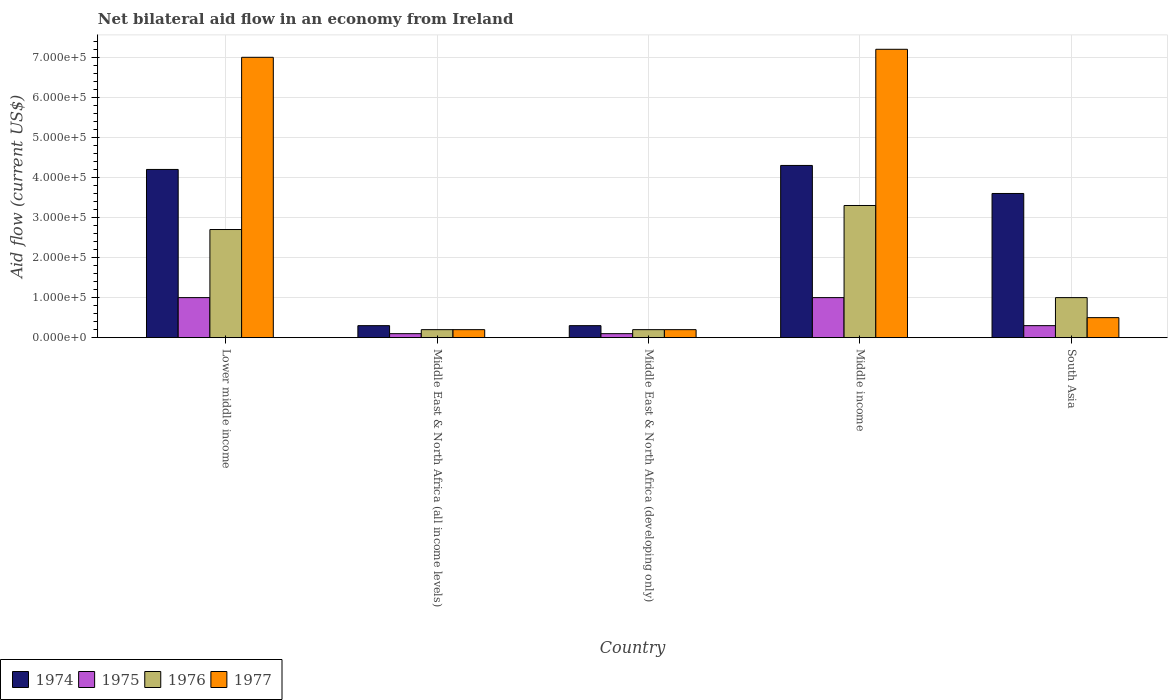How many groups of bars are there?
Your response must be concise. 5. Are the number of bars per tick equal to the number of legend labels?
Give a very brief answer. Yes. How many bars are there on the 5th tick from the right?
Provide a short and direct response. 4. What is the label of the 5th group of bars from the left?
Your answer should be compact. South Asia. In how many cases, is the number of bars for a given country not equal to the number of legend labels?
Keep it short and to the point. 0. Across all countries, what is the maximum net bilateral aid flow in 1977?
Give a very brief answer. 7.20e+05. In which country was the net bilateral aid flow in 1976 maximum?
Provide a short and direct response. Middle income. In which country was the net bilateral aid flow in 1977 minimum?
Your answer should be compact. Middle East & North Africa (all income levels). What is the total net bilateral aid flow in 1977 in the graph?
Your answer should be compact. 1.51e+06. What is the difference between the net bilateral aid flow in 1977 in Middle East & North Africa (all income levels) and that in Middle income?
Offer a terse response. -7.00e+05. What is the difference between the net bilateral aid flow in 1977 in Middle income and the net bilateral aid flow in 1975 in Middle East & North Africa (developing only)?
Make the answer very short. 7.10e+05. What is the average net bilateral aid flow in 1974 per country?
Provide a succinct answer. 2.54e+05. What is the ratio of the net bilateral aid flow in 1975 in Middle East & North Africa (developing only) to that in Middle income?
Provide a short and direct response. 0.1. Is the difference between the net bilateral aid flow in 1975 in Middle income and South Asia greater than the difference between the net bilateral aid flow in 1976 in Middle income and South Asia?
Provide a succinct answer. No. Is it the case that in every country, the sum of the net bilateral aid flow in 1974 and net bilateral aid flow in 1975 is greater than the sum of net bilateral aid flow in 1977 and net bilateral aid flow in 1976?
Offer a very short reply. No. What does the 2nd bar from the left in Middle East & North Africa (all income levels) represents?
Ensure brevity in your answer.  1975. Is it the case that in every country, the sum of the net bilateral aid flow in 1977 and net bilateral aid flow in 1976 is greater than the net bilateral aid flow in 1975?
Make the answer very short. Yes. How many countries are there in the graph?
Offer a very short reply. 5. Does the graph contain grids?
Provide a succinct answer. Yes. Where does the legend appear in the graph?
Ensure brevity in your answer.  Bottom left. How are the legend labels stacked?
Ensure brevity in your answer.  Horizontal. What is the title of the graph?
Your answer should be very brief. Net bilateral aid flow in an economy from Ireland. What is the label or title of the X-axis?
Your response must be concise. Country. What is the label or title of the Y-axis?
Keep it short and to the point. Aid flow (current US$). What is the Aid flow (current US$) of 1974 in Middle East & North Africa (all income levels)?
Your answer should be very brief. 3.00e+04. What is the Aid flow (current US$) of 1976 in Middle East & North Africa (all income levels)?
Offer a very short reply. 2.00e+04. What is the Aid flow (current US$) of 1977 in Middle East & North Africa (all income levels)?
Your answer should be compact. 2.00e+04. What is the Aid flow (current US$) of 1975 in Middle East & North Africa (developing only)?
Ensure brevity in your answer.  10000. What is the Aid flow (current US$) of 1974 in Middle income?
Your answer should be compact. 4.30e+05. What is the Aid flow (current US$) of 1975 in Middle income?
Your answer should be compact. 1.00e+05. What is the Aid flow (current US$) of 1976 in Middle income?
Your answer should be compact. 3.30e+05. What is the Aid flow (current US$) of 1977 in Middle income?
Make the answer very short. 7.20e+05. What is the Aid flow (current US$) in 1974 in South Asia?
Your answer should be very brief. 3.60e+05. What is the Aid flow (current US$) of 1975 in South Asia?
Keep it short and to the point. 3.00e+04. What is the Aid flow (current US$) of 1977 in South Asia?
Give a very brief answer. 5.00e+04. Across all countries, what is the maximum Aid flow (current US$) in 1977?
Offer a terse response. 7.20e+05. Across all countries, what is the minimum Aid flow (current US$) in 1976?
Ensure brevity in your answer.  2.00e+04. Across all countries, what is the minimum Aid flow (current US$) in 1977?
Make the answer very short. 2.00e+04. What is the total Aid flow (current US$) in 1974 in the graph?
Offer a terse response. 1.27e+06. What is the total Aid flow (current US$) in 1976 in the graph?
Give a very brief answer. 7.40e+05. What is the total Aid flow (current US$) in 1977 in the graph?
Provide a short and direct response. 1.51e+06. What is the difference between the Aid flow (current US$) in 1974 in Lower middle income and that in Middle East & North Africa (all income levels)?
Provide a succinct answer. 3.90e+05. What is the difference between the Aid flow (current US$) of 1975 in Lower middle income and that in Middle East & North Africa (all income levels)?
Your answer should be very brief. 9.00e+04. What is the difference between the Aid flow (current US$) of 1976 in Lower middle income and that in Middle East & North Africa (all income levels)?
Offer a terse response. 2.50e+05. What is the difference between the Aid flow (current US$) in 1977 in Lower middle income and that in Middle East & North Africa (all income levels)?
Provide a short and direct response. 6.80e+05. What is the difference between the Aid flow (current US$) of 1975 in Lower middle income and that in Middle East & North Africa (developing only)?
Your answer should be very brief. 9.00e+04. What is the difference between the Aid flow (current US$) in 1977 in Lower middle income and that in Middle East & North Africa (developing only)?
Offer a very short reply. 6.80e+05. What is the difference between the Aid flow (current US$) of 1974 in Lower middle income and that in Middle income?
Keep it short and to the point. -10000. What is the difference between the Aid flow (current US$) of 1975 in Lower middle income and that in Middle income?
Keep it short and to the point. 0. What is the difference between the Aid flow (current US$) of 1974 in Lower middle income and that in South Asia?
Provide a short and direct response. 6.00e+04. What is the difference between the Aid flow (current US$) of 1977 in Lower middle income and that in South Asia?
Make the answer very short. 6.50e+05. What is the difference between the Aid flow (current US$) of 1974 in Middle East & North Africa (all income levels) and that in Middle East & North Africa (developing only)?
Your response must be concise. 0. What is the difference between the Aid flow (current US$) of 1975 in Middle East & North Africa (all income levels) and that in Middle East & North Africa (developing only)?
Make the answer very short. 0. What is the difference between the Aid flow (current US$) in 1974 in Middle East & North Africa (all income levels) and that in Middle income?
Provide a short and direct response. -4.00e+05. What is the difference between the Aid flow (current US$) in 1976 in Middle East & North Africa (all income levels) and that in Middle income?
Ensure brevity in your answer.  -3.10e+05. What is the difference between the Aid flow (current US$) in 1977 in Middle East & North Africa (all income levels) and that in Middle income?
Keep it short and to the point. -7.00e+05. What is the difference between the Aid flow (current US$) in 1974 in Middle East & North Africa (all income levels) and that in South Asia?
Provide a succinct answer. -3.30e+05. What is the difference between the Aid flow (current US$) in 1975 in Middle East & North Africa (all income levels) and that in South Asia?
Your response must be concise. -2.00e+04. What is the difference between the Aid flow (current US$) of 1977 in Middle East & North Africa (all income levels) and that in South Asia?
Your answer should be very brief. -3.00e+04. What is the difference between the Aid flow (current US$) of 1974 in Middle East & North Africa (developing only) and that in Middle income?
Make the answer very short. -4.00e+05. What is the difference between the Aid flow (current US$) of 1975 in Middle East & North Africa (developing only) and that in Middle income?
Ensure brevity in your answer.  -9.00e+04. What is the difference between the Aid flow (current US$) in 1976 in Middle East & North Africa (developing only) and that in Middle income?
Provide a short and direct response. -3.10e+05. What is the difference between the Aid flow (current US$) in 1977 in Middle East & North Africa (developing only) and that in Middle income?
Your answer should be very brief. -7.00e+05. What is the difference between the Aid flow (current US$) in 1974 in Middle East & North Africa (developing only) and that in South Asia?
Ensure brevity in your answer.  -3.30e+05. What is the difference between the Aid flow (current US$) in 1975 in Middle East & North Africa (developing only) and that in South Asia?
Keep it short and to the point. -2.00e+04. What is the difference between the Aid flow (current US$) of 1977 in Middle East & North Africa (developing only) and that in South Asia?
Give a very brief answer. -3.00e+04. What is the difference between the Aid flow (current US$) of 1975 in Middle income and that in South Asia?
Keep it short and to the point. 7.00e+04. What is the difference between the Aid flow (current US$) of 1976 in Middle income and that in South Asia?
Provide a succinct answer. 2.30e+05. What is the difference between the Aid flow (current US$) in 1977 in Middle income and that in South Asia?
Your answer should be very brief. 6.70e+05. What is the difference between the Aid flow (current US$) in 1975 in Lower middle income and the Aid flow (current US$) in 1976 in Middle East & North Africa (all income levels)?
Your answer should be compact. 8.00e+04. What is the difference between the Aid flow (current US$) of 1975 in Lower middle income and the Aid flow (current US$) of 1977 in Middle East & North Africa (all income levels)?
Your answer should be very brief. 8.00e+04. What is the difference between the Aid flow (current US$) in 1976 in Lower middle income and the Aid flow (current US$) in 1977 in Middle East & North Africa (all income levels)?
Ensure brevity in your answer.  2.50e+05. What is the difference between the Aid flow (current US$) of 1974 in Lower middle income and the Aid flow (current US$) of 1976 in Middle East & North Africa (developing only)?
Your answer should be very brief. 4.00e+05. What is the difference between the Aid flow (current US$) in 1974 in Lower middle income and the Aid flow (current US$) in 1977 in Middle East & North Africa (developing only)?
Your answer should be very brief. 4.00e+05. What is the difference between the Aid flow (current US$) in 1975 in Lower middle income and the Aid flow (current US$) in 1977 in Middle East & North Africa (developing only)?
Offer a terse response. 8.00e+04. What is the difference between the Aid flow (current US$) in 1974 in Lower middle income and the Aid flow (current US$) in 1976 in Middle income?
Offer a very short reply. 9.00e+04. What is the difference between the Aid flow (current US$) in 1974 in Lower middle income and the Aid flow (current US$) in 1977 in Middle income?
Make the answer very short. -3.00e+05. What is the difference between the Aid flow (current US$) of 1975 in Lower middle income and the Aid flow (current US$) of 1977 in Middle income?
Give a very brief answer. -6.20e+05. What is the difference between the Aid flow (current US$) of 1976 in Lower middle income and the Aid flow (current US$) of 1977 in Middle income?
Offer a terse response. -4.50e+05. What is the difference between the Aid flow (current US$) of 1976 in Lower middle income and the Aid flow (current US$) of 1977 in South Asia?
Offer a terse response. 2.20e+05. What is the difference between the Aid flow (current US$) in 1974 in Middle East & North Africa (all income levels) and the Aid flow (current US$) in 1975 in Middle East & North Africa (developing only)?
Make the answer very short. 2.00e+04. What is the difference between the Aid flow (current US$) in 1974 in Middle East & North Africa (all income levels) and the Aid flow (current US$) in 1977 in Middle East & North Africa (developing only)?
Give a very brief answer. 10000. What is the difference between the Aid flow (current US$) of 1975 in Middle East & North Africa (all income levels) and the Aid flow (current US$) of 1977 in Middle East & North Africa (developing only)?
Your answer should be very brief. -10000. What is the difference between the Aid flow (current US$) of 1976 in Middle East & North Africa (all income levels) and the Aid flow (current US$) of 1977 in Middle East & North Africa (developing only)?
Your response must be concise. 0. What is the difference between the Aid flow (current US$) of 1974 in Middle East & North Africa (all income levels) and the Aid flow (current US$) of 1975 in Middle income?
Offer a terse response. -7.00e+04. What is the difference between the Aid flow (current US$) in 1974 in Middle East & North Africa (all income levels) and the Aid flow (current US$) in 1976 in Middle income?
Offer a very short reply. -3.00e+05. What is the difference between the Aid flow (current US$) of 1974 in Middle East & North Africa (all income levels) and the Aid flow (current US$) of 1977 in Middle income?
Your response must be concise. -6.90e+05. What is the difference between the Aid flow (current US$) of 1975 in Middle East & North Africa (all income levels) and the Aid flow (current US$) of 1976 in Middle income?
Ensure brevity in your answer.  -3.20e+05. What is the difference between the Aid flow (current US$) of 1975 in Middle East & North Africa (all income levels) and the Aid flow (current US$) of 1977 in Middle income?
Your response must be concise. -7.10e+05. What is the difference between the Aid flow (current US$) of 1976 in Middle East & North Africa (all income levels) and the Aid flow (current US$) of 1977 in Middle income?
Make the answer very short. -7.00e+05. What is the difference between the Aid flow (current US$) of 1974 in Middle East & North Africa (all income levels) and the Aid flow (current US$) of 1976 in South Asia?
Give a very brief answer. -7.00e+04. What is the difference between the Aid flow (current US$) in 1974 in Middle East & North Africa (all income levels) and the Aid flow (current US$) in 1977 in South Asia?
Provide a succinct answer. -2.00e+04. What is the difference between the Aid flow (current US$) of 1975 in Middle East & North Africa (all income levels) and the Aid flow (current US$) of 1976 in South Asia?
Give a very brief answer. -9.00e+04. What is the difference between the Aid flow (current US$) in 1974 in Middle East & North Africa (developing only) and the Aid flow (current US$) in 1976 in Middle income?
Offer a terse response. -3.00e+05. What is the difference between the Aid flow (current US$) in 1974 in Middle East & North Africa (developing only) and the Aid flow (current US$) in 1977 in Middle income?
Ensure brevity in your answer.  -6.90e+05. What is the difference between the Aid flow (current US$) of 1975 in Middle East & North Africa (developing only) and the Aid flow (current US$) of 1976 in Middle income?
Keep it short and to the point. -3.20e+05. What is the difference between the Aid flow (current US$) in 1975 in Middle East & North Africa (developing only) and the Aid flow (current US$) in 1977 in Middle income?
Offer a terse response. -7.10e+05. What is the difference between the Aid flow (current US$) of 1976 in Middle East & North Africa (developing only) and the Aid flow (current US$) of 1977 in Middle income?
Offer a very short reply. -7.00e+05. What is the difference between the Aid flow (current US$) of 1974 in Middle East & North Africa (developing only) and the Aid flow (current US$) of 1975 in South Asia?
Your answer should be very brief. 0. What is the difference between the Aid flow (current US$) of 1974 in Middle East & North Africa (developing only) and the Aid flow (current US$) of 1976 in South Asia?
Your answer should be compact. -7.00e+04. What is the difference between the Aid flow (current US$) of 1974 in Middle East & North Africa (developing only) and the Aid flow (current US$) of 1977 in South Asia?
Keep it short and to the point. -2.00e+04. What is the difference between the Aid flow (current US$) in 1976 in Middle East & North Africa (developing only) and the Aid flow (current US$) in 1977 in South Asia?
Keep it short and to the point. -3.00e+04. What is the difference between the Aid flow (current US$) in 1974 in Middle income and the Aid flow (current US$) in 1976 in South Asia?
Give a very brief answer. 3.30e+05. What is the difference between the Aid flow (current US$) of 1974 in Middle income and the Aid flow (current US$) of 1977 in South Asia?
Offer a terse response. 3.80e+05. What is the difference between the Aid flow (current US$) of 1975 in Middle income and the Aid flow (current US$) of 1977 in South Asia?
Give a very brief answer. 5.00e+04. What is the difference between the Aid flow (current US$) in 1976 in Middle income and the Aid flow (current US$) in 1977 in South Asia?
Provide a succinct answer. 2.80e+05. What is the average Aid flow (current US$) of 1974 per country?
Your answer should be very brief. 2.54e+05. What is the average Aid flow (current US$) in 1975 per country?
Offer a terse response. 5.00e+04. What is the average Aid flow (current US$) in 1976 per country?
Provide a succinct answer. 1.48e+05. What is the average Aid flow (current US$) of 1977 per country?
Your response must be concise. 3.02e+05. What is the difference between the Aid flow (current US$) of 1974 and Aid flow (current US$) of 1976 in Lower middle income?
Offer a terse response. 1.50e+05. What is the difference between the Aid flow (current US$) in 1974 and Aid flow (current US$) in 1977 in Lower middle income?
Make the answer very short. -2.80e+05. What is the difference between the Aid flow (current US$) in 1975 and Aid flow (current US$) in 1976 in Lower middle income?
Provide a succinct answer. -1.70e+05. What is the difference between the Aid flow (current US$) of 1975 and Aid flow (current US$) of 1977 in Lower middle income?
Your answer should be very brief. -6.00e+05. What is the difference between the Aid flow (current US$) of 1976 and Aid flow (current US$) of 1977 in Lower middle income?
Your answer should be compact. -4.30e+05. What is the difference between the Aid flow (current US$) of 1974 and Aid flow (current US$) of 1976 in Middle East & North Africa (all income levels)?
Offer a very short reply. 10000. What is the difference between the Aid flow (current US$) in 1975 and Aid flow (current US$) in 1976 in Middle East & North Africa (all income levels)?
Make the answer very short. -10000. What is the difference between the Aid flow (current US$) in 1975 and Aid flow (current US$) in 1977 in Middle East & North Africa (all income levels)?
Keep it short and to the point. -10000. What is the difference between the Aid flow (current US$) in 1974 and Aid flow (current US$) in 1975 in Middle East & North Africa (developing only)?
Your response must be concise. 2.00e+04. What is the difference between the Aid flow (current US$) of 1974 and Aid flow (current US$) of 1976 in Middle East & North Africa (developing only)?
Provide a short and direct response. 10000. What is the difference between the Aid flow (current US$) in 1975 and Aid flow (current US$) in 1976 in Middle income?
Your answer should be very brief. -2.30e+05. What is the difference between the Aid flow (current US$) in 1975 and Aid flow (current US$) in 1977 in Middle income?
Make the answer very short. -6.20e+05. What is the difference between the Aid flow (current US$) in 1976 and Aid flow (current US$) in 1977 in Middle income?
Offer a very short reply. -3.90e+05. What is the difference between the Aid flow (current US$) of 1974 and Aid flow (current US$) of 1976 in South Asia?
Make the answer very short. 2.60e+05. What is the difference between the Aid flow (current US$) in 1974 and Aid flow (current US$) in 1977 in South Asia?
Keep it short and to the point. 3.10e+05. What is the difference between the Aid flow (current US$) of 1975 and Aid flow (current US$) of 1976 in South Asia?
Your answer should be very brief. -7.00e+04. What is the difference between the Aid flow (current US$) of 1975 and Aid flow (current US$) of 1977 in South Asia?
Your response must be concise. -2.00e+04. What is the ratio of the Aid flow (current US$) in 1976 in Lower middle income to that in Middle East & North Africa (all income levels)?
Your response must be concise. 13.5. What is the ratio of the Aid flow (current US$) of 1977 in Lower middle income to that in Middle East & North Africa (developing only)?
Ensure brevity in your answer.  35. What is the ratio of the Aid flow (current US$) of 1974 in Lower middle income to that in Middle income?
Offer a terse response. 0.98. What is the ratio of the Aid flow (current US$) of 1975 in Lower middle income to that in Middle income?
Provide a short and direct response. 1. What is the ratio of the Aid flow (current US$) in 1976 in Lower middle income to that in Middle income?
Offer a terse response. 0.82. What is the ratio of the Aid flow (current US$) of 1977 in Lower middle income to that in Middle income?
Keep it short and to the point. 0.97. What is the ratio of the Aid flow (current US$) of 1974 in Lower middle income to that in South Asia?
Keep it short and to the point. 1.17. What is the ratio of the Aid flow (current US$) of 1977 in Lower middle income to that in South Asia?
Your answer should be very brief. 14. What is the ratio of the Aid flow (current US$) in 1975 in Middle East & North Africa (all income levels) to that in Middle East & North Africa (developing only)?
Give a very brief answer. 1. What is the ratio of the Aid flow (current US$) of 1977 in Middle East & North Africa (all income levels) to that in Middle East & North Africa (developing only)?
Keep it short and to the point. 1. What is the ratio of the Aid flow (current US$) of 1974 in Middle East & North Africa (all income levels) to that in Middle income?
Your answer should be compact. 0.07. What is the ratio of the Aid flow (current US$) in 1976 in Middle East & North Africa (all income levels) to that in Middle income?
Your answer should be very brief. 0.06. What is the ratio of the Aid flow (current US$) in 1977 in Middle East & North Africa (all income levels) to that in Middle income?
Provide a succinct answer. 0.03. What is the ratio of the Aid flow (current US$) of 1974 in Middle East & North Africa (all income levels) to that in South Asia?
Provide a short and direct response. 0.08. What is the ratio of the Aid flow (current US$) in 1975 in Middle East & North Africa (all income levels) to that in South Asia?
Ensure brevity in your answer.  0.33. What is the ratio of the Aid flow (current US$) of 1976 in Middle East & North Africa (all income levels) to that in South Asia?
Offer a terse response. 0.2. What is the ratio of the Aid flow (current US$) of 1974 in Middle East & North Africa (developing only) to that in Middle income?
Give a very brief answer. 0.07. What is the ratio of the Aid flow (current US$) in 1975 in Middle East & North Africa (developing only) to that in Middle income?
Keep it short and to the point. 0.1. What is the ratio of the Aid flow (current US$) in 1976 in Middle East & North Africa (developing only) to that in Middle income?
Make the answer very short. 0.06. What is the ratio of the Aid flow (current US$) of 1977 in Middle East & North Africa (developing only) to that in Middle income?
Your response must be concise. 0.03. What is the ratio of the Aid flow (current US$) in 1974 in Middle East & North Africa (developing only) to that in South Asia?
Provide a succinct answer. 0.08. What is the ratio of the Aid flow (current US$) of 1975 in Middle East & North Africa (developing only) to that in South Asia?
Give a very brief answer. 0.33. What is the ratio of the Aid flow (current US$) of 1976 in Middle East & North Africa (developing only) to that in South Asia?
Give a very brief answer. 0.2. What is the ratio of the Aid flow (current US$) in 1974 in Middle income to that in South Asia?
Provide a short and direct response. 1.19. What is the ratio of the Aid flow (current US$) in 1975 in Middle income to that in South Asia?
Your answer should be compact. 3.33. What is the ratio of the Aid flow (current US$) of 1976 in Middle income to that in South Asia?
Your answer should be compact. 3.3. What is the ratio of the Aid flow (current US$) of 1977 in Middle income to that in South Asia?
Provide a succinct answer. 14.4. What is the difference between the highest and the second highest Aid flow (current US$) in 1974?
Provide a succinct answer. 10000. What is the difference between the highest and the second highest Aid flow (current US$) of 1976?
Your answer should be compact. 6.00e+04. What is the difference between the highest and the second highest Aid flow (current US$) of 1977?
Provide a succinct answer. 2.00e+04. What is the difference between the highest and the lowest Aid flow (current US$) of 1974?
Offer a terse response. 4.00e+05. What is the difference between the highest and the lowest Aid flow (current US$) in 1975?
Keep it short and to the point. 9.00e+04. 